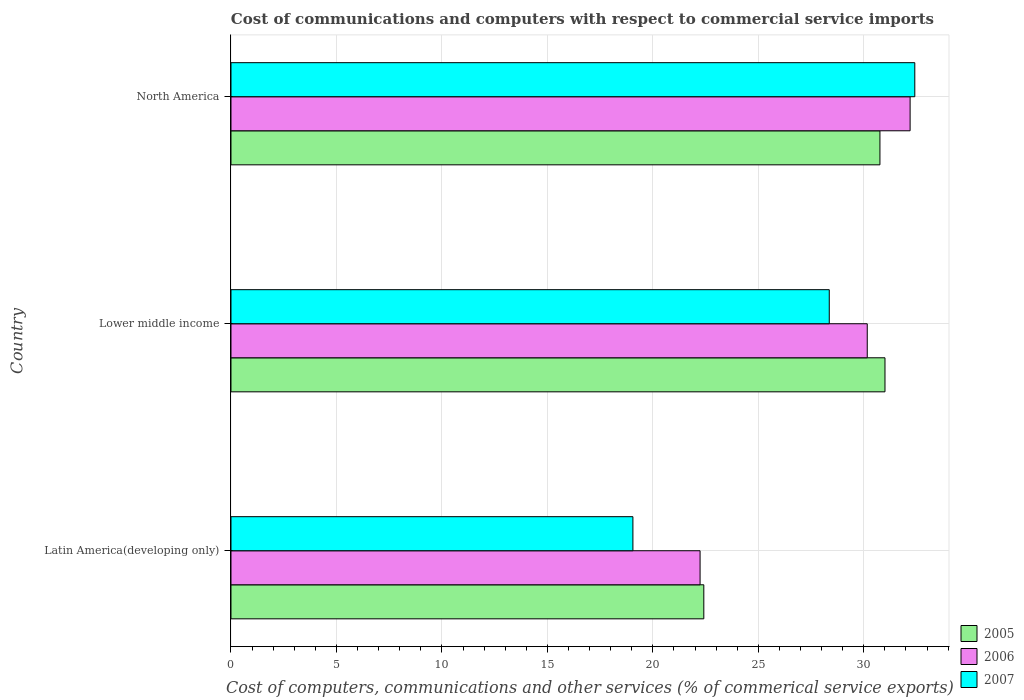Are the number of bars per tick equal to the number of legend labels?
Your answer should be very brief. Yes. Are the number of bars on each tick of the Y-axis equal?
Your answer should be very brief. Yes. How many bars are there on the 3rd tick from the bottom?
Your response must be concise. 3. What is the label of the 1st group of bars from the top?
Offer a terse response. North America. In how many cases, is the number of bars for a given country not equal to the number of legend labels?
Offer a very short reply. 0. What is the cost of communications and computers in 2007 in Latin America(developing only)?
Your response must be concise. 19.05. Across all countries, what is the maximum cost of communications and computers in 2005?
Offer a terse response. 31. Across all countries, what is the minimum cost of communications and computers in 2005?
Provide a short and direct response. 22.42. In which country was the cost of communications and computers in 2005 maximum?
Ensure brevity in your answer.  Lower middle income. In which country was the cost of communications and computers in 2005 minimum?
Provide a short and direct response. Latin America(developing only). What is the total cost of communications and computers in 2007 in the graph?
Your answer should be very brief. 79.84. What is the difference between the cost of communications and computers in 2005 in Latin America(developing only) and that in North America?
Make the answer very short. -8.35. What is the difference between the cost of communications and computers in 2006 in North America and the cost of communications and computers in 2007 in Latin America(developing only)?
Give a very brief answer. 13.14. What is the average cost of communications and computers in 2005 per country?
Provide a succinct answer. 28.06. What is the difference between the cost of communications and computers in 2005 and cost of communications and computers in 2007 in North America?
Make the answer very short. -1.65. What is the ratio of the cost of communications and computers in 2005 in Latin America(developing only) to that in Lower middle income?
Offer a very short reply. 0.72. Is the difference between the cost of communications and computers in 2005 in Lower middle income and North America greater than the difference between the cost of communications and computers in 2007 in Lower middle income and North America?
Provide a short and direct response. Yes. What is the difference between the highest and the second highest cost of communications and computers in 2005?
Provide a succinct answer. 0.24. What is the difference between the highest and the lowest cost of communications and computers in 2005?
Your response must be concise. 8.59. How many countries are there in the graph?
Your response must be concise. 3. What is the difference between two consecutive major ticks on the X-axis?
Provide a short and direct response. 5. Are the values on the major ticks of X-axis written in scientific E-notation?
Provide a succinct answer. No. Where does the legend appear in the graph?
Keep it short and to the point. Bottom right. How are the legend labels stacked?
Your response must be concise. Vertical. What is the title of the graph?
Your answer should be compact. Cost of communications and computers with respect to commercial service imports. What is the label or title of the X-axis?
Your answer should be compact. Cost of computers, communications and other services (% of commerical service exports). What is the Cost of computers, communications and other services (% of commerical service exports) of 2005 in Latin America(developing only)?
Ensure brevity in your answer.  22.42. What is the Cost of computers, communications and other services (% of commerical service exports) in 2006 in Latin America(developing only)?
Your response must be concise. 22.24. What is the Cost of computers, communications and other services (% of commerical service exports) of 2007 in Latin America(developing only)?
Provide a short and direct response. 19.05. What is the Cost of computers, communications and other services (% of commerical service exports) of 2005 in Lower middle income?
Keep it short and to the point. 31. What is the Cost of computers, communications and other services (% of commerical service exports) of 2006 in Lower middle income?
Your answer should be compact. 30.16. What is the Cost of computers, communications and other services (% of commerical service exports) in 2007 in Lower middle income?
Give a very brief answer. 28.36. What is the Cost of computers, communications and other services (% of commerical service exports) in 2005 in North America?
Provide a succinct answer. 30.77. What is the Cost of computers, communications and other services (% of commerical service exports) in 2006 in North America?
Your response must be concise. 32.2. What is the Cost of computers, communications and other services (% of commerical service exports) of 2007 in North America?
Make the answer very short. 32.42. Across all countries, what is the maximum Cost of computers, communications and other services (% of commerical service exports) of 2005?
Provide a short and direct response. 31. Across all countries, what is the maximum Cost of computers, communications and other services (% of commerical service exports) of 2006?
Offer a terse response. 32.2. Across all countries, what is the maximum Cost of computers, communications and other services (% of commerical service exports) in 2007?
Provide a short and direct response. 32.42. Across all countries, what is the minimum Cost of computers, communications and other services (% of commerical service exports) of 2005?
Offer a very short reply. 22.42. Across all countries, what is the minimum Cost of computers, communications and other services (% of commerical service exports) in 2006?
Ensure brevity in your answer.  22.24. Across all countries, what is the minimum Cost of computers, communications and other services (% of commerical service exports) of 2007?
Provide a succinct answer. 19.05. What is the total Cost of computers, communications and other services (% of commerical service exports) of 2005 in the graph?
Your answer should be compact. 84.19. What is the total Cost of computers, communications and other services (% of commerical service exports) of 2006 in the graph?
Make the answer very short. 84.6. What is the total Cost of computers, communications and other services (% of commerical service exports) of 2007 in the graph?
Your answer should be very brief. 79.84. What is the difference between the Cost of computers, communications and other services (% of commerical service exports) in 2005 in Latin America(developing only) and that in Lower middle income?
Ensure brevity in your answer.  -8.59. What is the difference between the Cost of computers, communications and other services (% of commerical service exports) of 2006 in Latin America(developing only) and that in Lower middle income?
Offer a very short reply. -7.93. What is the difference between the Cost of computers, communications and other services (% of commerical service exports) in 2007 in Latin America(developing only) and that in Lower middle income?
Offer a very short reply. -9.31. What is the difference between the Cost of computers, communications and other services (% of commerical service exports) of 2005 in Latin America(developing only) and that in North America?
Provide a short and direct response. -8.35. What is the difference between the Cost of computers, communications and other services (% of commerical service exports) in 2006 in Latin America(developing only) and that in North America?
Your answer should be very brief. -9.96. What is the difference between the Cost of computers, communications and other services (% of commerical service exports) in 2007 in Latin America(developing only) and that in North America?
Offer a very short reply. -13.36. What is the difference between the Cost of computers, communications and other services (% of commerical service exports) of 2005 in Lower middle income and that in North America?
Keep it short and to the point. 0.24. What is the difference between the Cost of computers, communications and other services (% of commerical service exports) of 2006 in Lower middle income and that in North America?
Provide a succinct answer. -2.03. What is the difference between the Cost of computers, communications and other services (% of commerical service exports) of 2007 in Lower middle income and that in North America?
Your response must be concise. -4.05. What is the difference between the Cost of computers, communications and other services (% of commerical service exports) of 2005 in Latin America(developing only) and the Cost of computers, communications and other services (% of commerical service exports) of 2006 in Lower middle income?
Your answer should be very brief. -7.75. What is the difference between the Cost of computers, communications and other services (% of commerical service exports) of 2005 in Latin America(developing only) and the Cost of computers, communications and other services (% of commerical service exports) of 2007 in Lower middle income?
Your answer should be very brief. -5.95. What is the difference between the Cost of computers, communications and other services (% of commerical service exports) in 2006 in Latin America(developing only) and the Cost of computers, communications and other services (% of commerical service exports) in 2007 in Lower middle income?
Keep it short and to the point. -6.12. What is the difference between the Cost of computers, communications and other services (% of commerical service exports) of 2005 in Latin America(developing only) and the Cost of computers, communications and other services (% of commerical service exports) of 2006 in North America?
Make the answer very short. -9.78. What is the difference between the Cost of computers, communications and other services (% of commerical service exports) in 2005 in Latin America(developing only) and the Cost of computers, communications and other services (% of commerical service exports) in 2007 in North America?
Provide a succinct answer. -10. What is the difference between the Cost of computers, communications and other services (% of commerical service exports) of 2006 in Latin America(developing only) and the Cost of computers, communications and other services (% of commerical service exports) of 2007 in North America?
Ensure brevity in your answer.  -10.18. What is the difference between the Cost of computers, communications and other services (% of commerical service exports) in 2005 in Lower middle income and the Cost of computers, communications and other services (% of commerical service exports) in 2006 in North America?
Make the answer very short. -1.19. What is the difference between the Cost of computers, communications and other services (% of commerical service exports) of 2005 in Lower middle income and the Cost of computers, communications and other services (% of commerical service exports) of 2007 in North America?
Make the answer very short. -1.41. What is the difference between the Cost of computers, communications and other services (% of commerical service exports) in 2006 in Lower middle income and the Cost of computers, communications and other services (% of commerical service exports) in 2007 in North America?
Provide a short and direct response. -2.25. What is the average Cost of computers, communications and other services (% of commerical service exports) in 2005 per country?
Your answer should be very brief. 28.06. What is the average Cost of computers, communications and other services (% of commerical service exports) in 2006 per country?
Offer a very short reply. 28.2. What is the average Cost of computers, communications and other services (% of commerical service exports) of 2007 per country?
Your answer should be very brief. 26.61. What is the difference between the Cost of computers, communications and other services (% of commerical service exports) in 2005 and Cost of computers, communications and other services (% of commerical service exports) in 2006 in Latin America(developing only)?
Ensure brevity in your answer.  0.18. What is the difference between the Cost of computers, communications and other services (% of commerical service exports) in 2005 and Cost of computers, communications and other services (% of commerical service exports) in 2007 in Latin America(developing only)?
Your answer should be compact. 3.36. What is the difference between the Cost of computers, communications and other services (% of commerical service exports) in 2006 and Cost of computers, communications and other services (% of commerical service exports) in 2007 in Latin America(developing only)?
Your response must be concise. 3.18. What is the difference between the Cost of computers, communications and other services (% of commerical service exports) of 2005 and Cost of computers, communications and other services (% of commerical service exports) of 2006 in Lower middle income?
Your response must be concise. 0.84. What is the difference between the Cost of computers, communications and other services (% of commerical service exports) of 2005 and Cost of computers, communications and other services (% of commerical service exports) of 2007 in Lower middle income?
Ensure brevity in your answer.  2.64. What is the difference between the Cost of computers, communications and other services (% of commerical service exports) in 2006 and Cost of computers, communications and other services (% of commerical service exports) in 2007 in Lower middle income?
Give a very brief answer. 1.8. What is the difference between the Cost of computers, communications and other services (% of commerical service exports) in 2005 and Cost of computers, communications and other services (% of commerical service exports) in 2006 in North America?
Offer a very short reply. -1.43. What is the difference between the Cost of computers, communications and other services (% of commerical service exports) of 2005 and Cost of computers, communications and other services (% of commerical service exports) of 2007 in North America?
Ensure brevity in your answer.  -1.65. What is the difference between the Cost of computers, communications and other services (% of commerical service exports) of 2006 and Cost of computers, communications and other services (% of commerical service exports) of 2007 in North America?
Give a very brief answer. -0.22. What is the ratio of the Cost of computers, communications and other services (% of commerical service exports) in 2005 in Latin America(developing only) to that in Lower middle income?
Give a very brief answer. 0.72. What is the ratio of the Cost of computers, communications and other services (% of commerical service exports) of 2006 in Latin America(developing only) to that in Lower middle income?
Give a very brief answer. 0.74. What is the ratio of the Cost of computers, communications and other services (% of commerical service exports) in 2007 in Latin America(developing only) to that in Lower middle income?
Provide a short and direct response. 0.67. What is the ratio of the Cost of computers, communications and other services (% of commerical service exports) of 2005 in Latin America(developing only) to that in North America?
Provide a succinct answer. 0.73. What is the ratio of the Cost of computers, communications and other services (% of commerical service exports) of 2006 in Latin America(developing only) to that in North America?
Keep it short and to the point. 0.69. What is the ratio of the Cost of computers, communications and other services (% of commerical service exports) of 2007 in Latin America(developing only) to that in North America?
Keep it short and to the point. 0.59. What is the ratio of the Cost of computers, communications and other services (% of commerical service exports) of 2005 in Lower middle income to that in North America?
Your response must be concise. 1.01. What is the ratio of the Cost of computers, communications and other services (% of commerical service exports) in 2006 in Lower middle income to that in North America?
Offer a terse response. 0.94. What is the ratio of the Cost of computers, communications and other services (% of commerical service exports) in 2007 in Lower middle income to that in North America?
Provide a short and direct response. 0.87. What is the difference between the highest and the second highest Cost of computers, communications and other services (% of commerical service exports) of 2005?
Give a very brief answer. 0.24. What is the difference between the highest and the second highest Cost of computers, communications and other services (% of commerical service exports) of 2006?
Your answer should be very brief. 2.03. What is the difference between the highest and the second highest Cost of computers, communications and other services (% of commerical service exports) in 2007?
Offer a terse response. 4.05. What is the difference between the highest and the lowest Cost of computers, communications and other services (% of commerical service exports) of 2005?
Provide a short and direct response. 8.59. What is the difference between the highest and the lowest Cost of computers, communications and other services (% of commerical service exports) in 2006?
Give a very brief answer. 9.96. What is the difference between the highest and the lowest Cost of computers, communications and other services (% of commerical service exports) of 2007?
Your response must be concise. 13.36. 